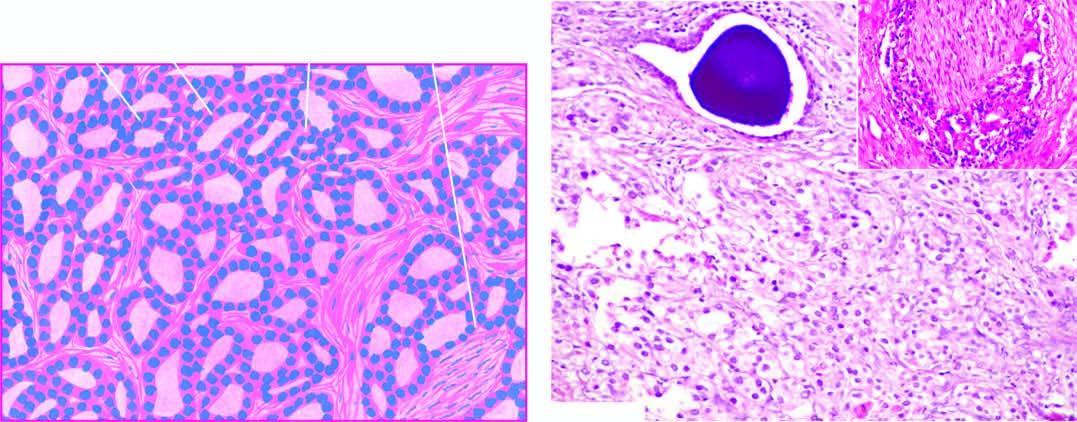does the field show microacini of small malignant cells infiltrating the prostatic stroma?
Answer the question using a single word or phrase. Yes 